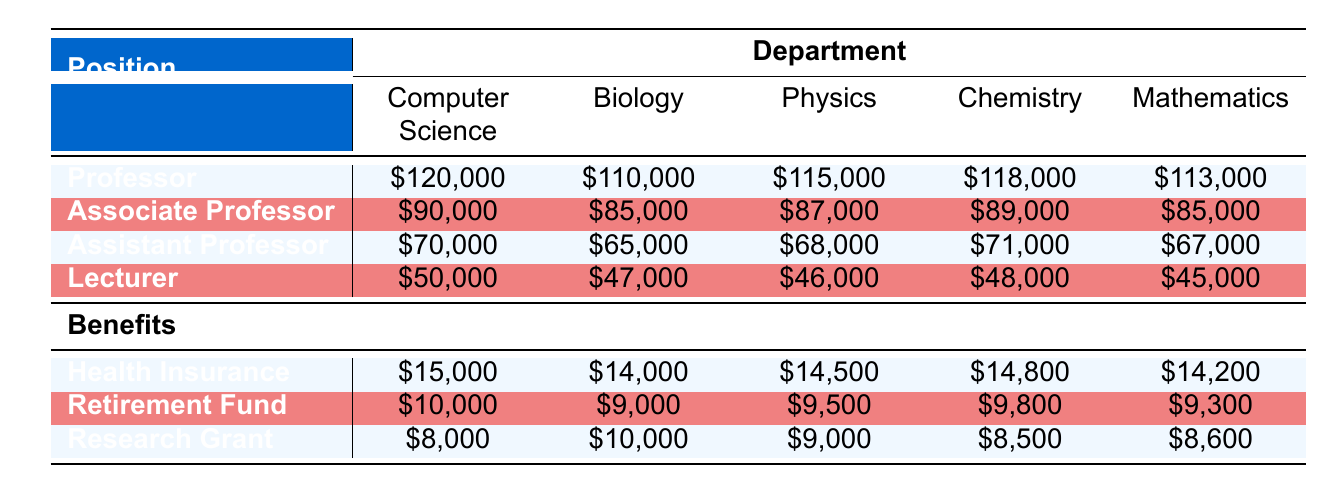What is the salary of an Assistant Professor in the Computer Science department? The salary of an Assistant Professor in the Computer Science department is given directly in the table. It states \$70,000.
Answer: \$70,000 Which department offers the highest salary for a Professor position? To find the highest salary for a Professor, look at the salary figures for all departments under the Professor row. The values are \$120,000 (Computer Science), \$110,000 (Biology), \$115,000 (Physics), \$118,000 (Chemistry), and \$113,000 (Mathematics). The highest is \$120,000.
Answer: Computer Science What is the average salary of Associate Professors across all departments? The salaries of Associate Professors are \$90,000 (Computer Science), \$85,000 (Biology), \$87,000 (Physics), \$89,000 (Chemistry), and \$85,000 (Mathematics). To find the average, sum these values: 90,000 + 85,000 + 87,000 + 89,000 + 85,000 = 436,000. Then divide by the number of departments (5): 436,000 / 5 = 87,200.
Answer: \$87,200 Does the Biology department offer more health insurance benefits than the Physics department? The health insurance benefits for Biology is \$14,000 and for Physics is \$14,500. Comparing these values, \$14,000 (Biology) is less than \$14,500 (Physics). Therefore, Biology does not offer more benefits.
Answer: No Which position has the smallest retirement fund benefit in the Chemistry department? Look at the retirement fund benefits specifically for the Chemistry department. The values are \$9,800 (Professor), \$7,400 (Associate Professor), \$5,400 (Assistant Professor), and \$3,400 (Lecturer). The smallest among these is \$3,400 associated with the Lecturer position.
Answer: \$3,400 What is the total financial compensation (salary plus benefits) for an Assistant Professor in the Physics department? For the Physics department, the salary of an Assistant Professor is \$68,000. The benefits associated with this role includes health insurance (\$9,800), retirement fund (\$5,200), and research grant (\$4,800). So, add these amounts together: 68,000 + 9,800 + 5,200 + 4,800 = 87,800.
Answer: \$87,800 Which department has the lowest salary for the Lecturer position? The salary for Lecturers across departments is \$50,000 (Computer Science), \$47,000 (Biology), \$46,000 (Physics), \$48,000 (Chemistry), and \$45,000 (Mathematics). Finding the minimum salary: \$46,000 (Physics) is the lowest.
Answer: Physics Is the total benefits package higher for an Assistant Professor in Mathematics than for an Associate Professor in Biology? The total benefits for an Assistant Professor in Mathematics includes: health insurance (\$9,700), retirement fund (\$5,100), research grant (\$4,700), which totals to \$19,500. For an Associate Professor in Biology: health insurance (\$11,000), retirement fund (\$7,000), research grant (\$8,000), which totals to \$26,000. Comparing \$19,500 and \$26,000 shows that Mathematics has a lower total benefits package.
Answer: No What percentage of the salary of a Professor in Computer Science is covered by health insurance benefits? The salary of a Professor in Computer Science is \$120,000 and the health insurance benefit is \$15,000. To find the percentage, use the formula: (health insurance / salary) * 100 = (15,000 / 120,000) * 100 = 12.5%.
Answer: 12.5% 